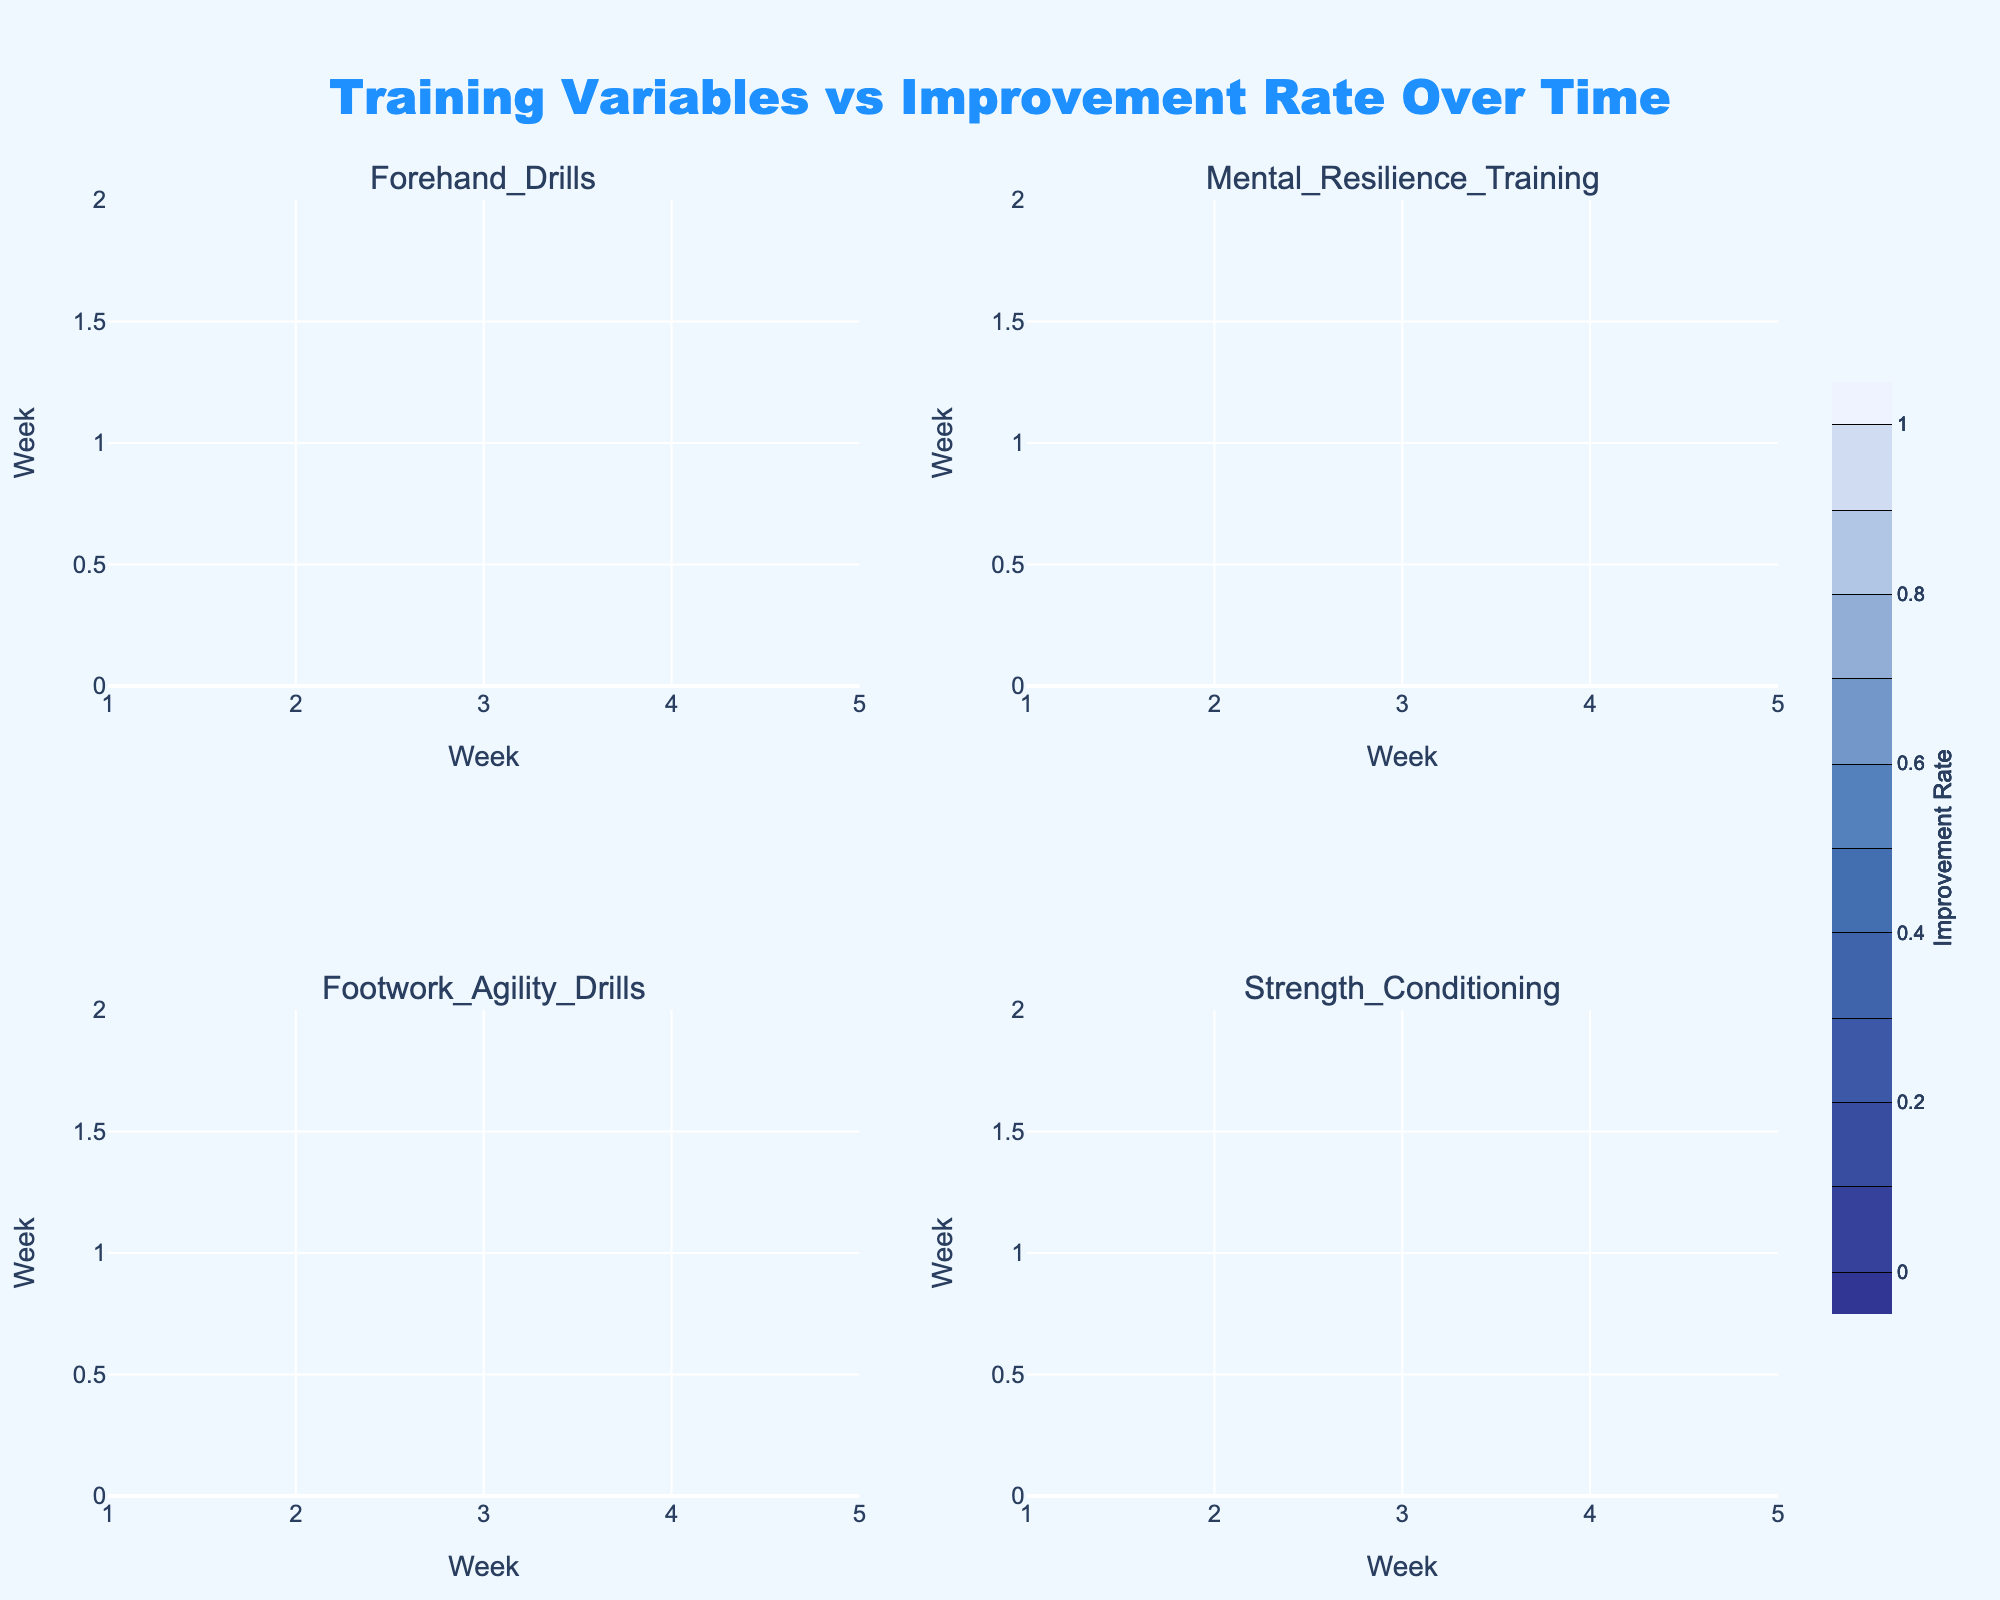What is the title of the figure? The title of the figure is prominently positioned at the top of the visual. It is styled to stand out, making it easily identifiable.
Answer: Training Variables vs Improvement Rate Over Time How many training variables are compared in the figure? The subtitle of each subplot indicates one of the training variables, and there are four subplots in total. So, there are four training variables compared.
Answer: Four Which training variable shows the highest improvement rate by Week 5? To find the training variable with the highest improvement rate by Week 5, look at the contour values at Week 5 for each subplot. From the data, Forehand Drills have the highest improvement rate (0.9) at Week 5.
Answer: Forehand Drills What is the range of the color scale used in the figure? The color scale is indicated in the legend, which typically shows the minimum and maximum values it represents. Here, the legend shows a range from 0 to 1.
Answer: 0 to 1 Which weeks display an improvement rate of at least 0.7 for the Mental Resilience Training? Check the contour plot corresponding to Mental Resilience Training. Values at or above 0.7 appear from Week 4 and Week 5.
Answer: Weeks 4 and 5 Which two training variables have the same improvement rate in Week 2? By examining the contours at Week 2 across all subplots, Forehand Drills and Mental Resilience Training both show an improvement rate of 0.5 in Week 2.
Answer: Forehand Drills and Mental Resilience Training Is the improvement rate higher for Footwork Agility Drills or Strength Conditioning in Week 3? Compare the contours at Week 3 for both subplots. Footwork Agility Drills have an improvement rate of 0.5 while Strength Conditioning has 0.4. Thus, the improvement rate is higher for Footwork Agility Drills.
Answer: Footwork Agility Drills What trend do you observe in the improvement rates for the Strength Conditioning over the 5 weeks? The contours show a consistent increase in improvement rate over the weeks for Strength Conditioning, starting at 0.2 in Week 1 and reaching 0.6 by Week 5.
Answer: Increasing trend In which subplot is the steepest improvement trend observed, and what might this indicate? The steepest improvement trend is observed by examining the contours' gradient across the weeks. Forehand Drills subplots show the steepest trend. This indicates that intensive enhancement is achieved quickly for this variable.
Answer: Forehand Drills Which subplot has the least improvement rate across the weeks? To find the subplot with the least improvement rate, observe which one consistently has lower values across the weeks. Strength Conditioning consistently shows lower improvement rates compared to the others.
Answer: Strength Conditioning 